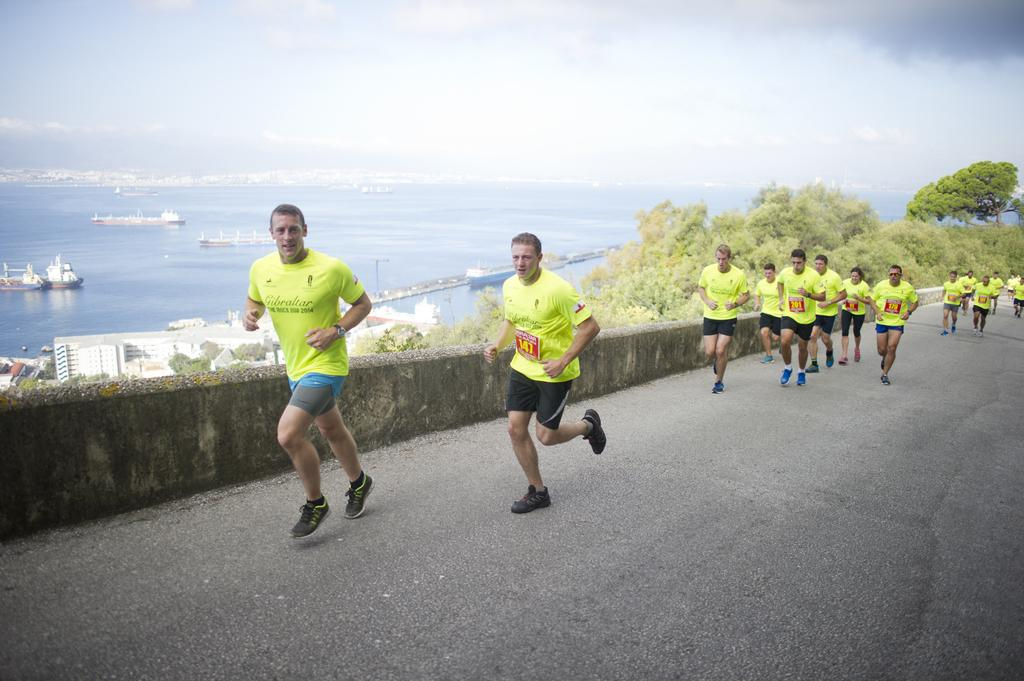What is happening in the image? There is a group of men running on the road. What can be seen in the background of the image? There are buildings, trees, water, ships, and the sky visible in the background. What is the condition of the sky in the image? Clouds are present in the sky. What type of scent can be detected in the image? There is no mention of a scent in the image, so it cannot be determined from the image. --- Facts: 1. There is a car in the image. 2. The car is parked on the street. 3. There are people walking on the sidewalk. 4. There is a tree on the sidewalk. 5. The sky is visible in the image. 6. The sun is visible in the sky. Absurd Topics: parrot, dance, ocean Conversation: What is the main subject of the image? The main subject of the image is a car. Where is the car located in the image? The car is parked on the street. What else can be seen in the image besides the car? There are people walking on the sidewalk and a tree on the sidewalk. What is visible in the sky in the image? The sky is visible in the image, and the sun is visible in the sky. Reasoning: Let's think step by step in order to produce the conversation. We start by identifying the main subject of the image, which is the car. Then, we describe the location of the car and the other elements that can be seen in the image, such as the people walking and the tree on the sidewalk. Finally, we focus on the sky and its condition, noting the presence of the sun. Absurd Question/Answer: Can you tell me how many parrots are sitting on the car in the image? There are no parrots present in the image, so it cannot be determined from the image. 